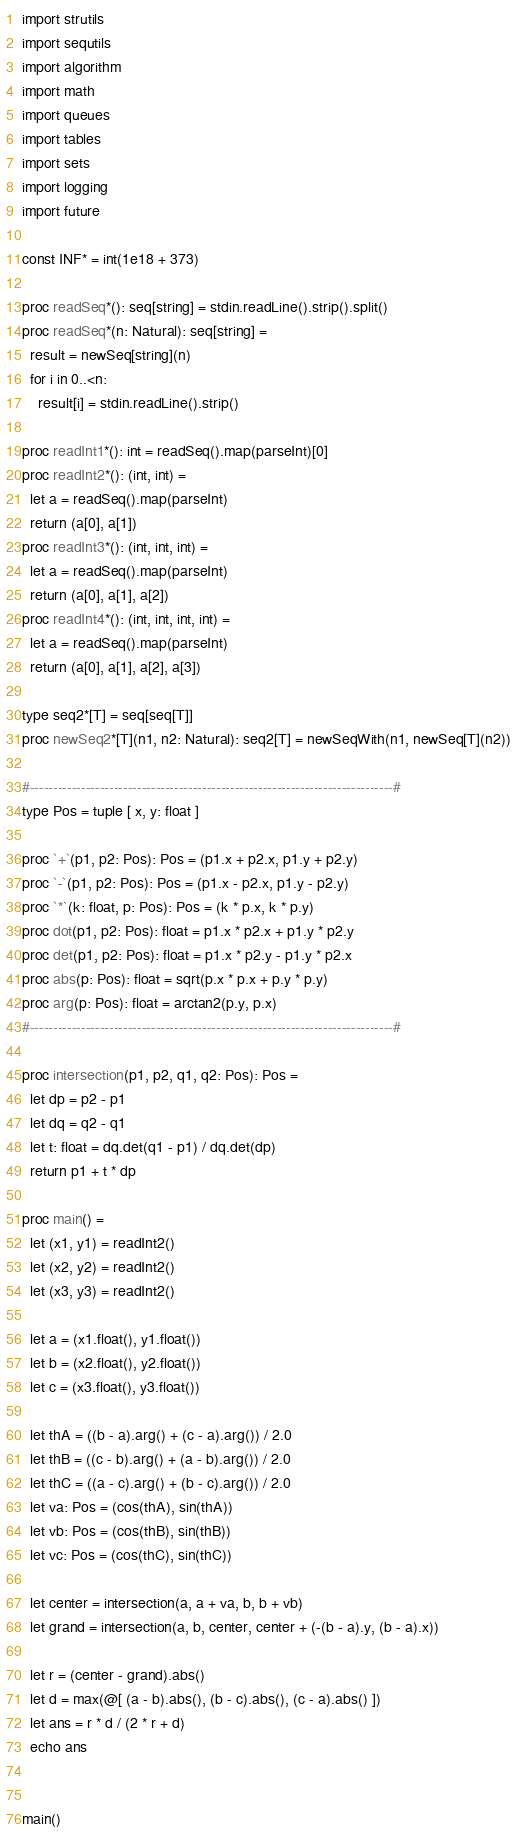Convert code to text. <code><loc_0><loc_0><loc_500><loc_500><_Nim_>import strutils
import sequtils
import algorithm
import math
import queues
import tables
import sets
import logging
import future

const INF* = int(1e18 + 373)

proc readSeq*(): seq[string] = stdin.readLine().strip().split()
proc readSeq*(n: Natural): seq[string] =
  result = newSeq[string](n)
  for i in 0..<n:
    result[i] = stdin.readLine().strip()

proc readInt1*(): int = readSeq().map(parseInt)[0]
proc readInt2*(): (int, int) =
  let a = readSeq().map(parseInt)
  return (a[0], a[1])
proc readInt3*(): (int, int, int) =
  let a = readSeq().map(parseInt)
  return (a[0], a[1], a[2])
proc readInt4*(): (int, int, int, int) =
  let a = readSeq().map(parseInt)
  return (a[0], a[1], a[2], a[3])

type seq2*[T] = seq[seq[T]]
proc newSeq2*[T](n1, n2: Natural): seq2[T] = newSeqWith(n1, newSeq[T](n2))

#------------------------------------------------------------------------------#
type Pos = tuple [ x, y: float ]

proc `+`(p1, p2: Pos): Pos = (p1.x + p2.x, p1.y + p2.y)
proc `-`(p1, p2: Pos): Pos = (p1.x - p2.x, p1.y - p2.y)
proc `*`(k: float, p: Pos): Pos = (k * p.x, k * p.y)
proc dot(p1, p2: Pos): float = p1.x * p2.x + p1.y * p2.y
proc det(p1, p2: Pos): float = p1.x * p2.y - p1.y * p2.x
proc abs(p: Pos): float = sqrt(p.x * p.x + p.y * p.y)
proc arg(p: Pos): float = arctan2(p.y, p.x)
#------------------------------------------------------------------------------#

proc intersection(p1, p2, q1, q2: Pos): Pos =
  let dp = p2 - p1
  let dq = q2 - q1
  let t: float = dq.det(q1 - p1) / dq.det(dp)
  return p1 + t * dp

proc main() =
  let (x1, y1) = readInt2()
  let (x2, y2) = readInt2()
  let (x3, y3) = readInt2()

  let a = (x1.float(), y1.float())
  let b = (x2.float(), y2.float())
  let c = (x3.float(), y3.float())

  let thA = ((b - a).arg() + (c - a).arg()) / 2.0
  let thB = ((c - b).arg() + (a - b).arg()) / 2.0
  let thC = ((a - c).arg() + (b - c).arg()) / 2.0
  let va: Pos = (cos(thA), sin(thA))
  let vb: Pos = (cos(thB), sin(thB))
  let vc: Pos = (cos(thC), sin(thC))

  let center = intersection(a, a + va, b, b + vb)
  let grand = intersection(a, b, center, center + (-(b - a).y, (b - a).x))

  let r = (center - grand).abs()
  let d = max(@[ (a - b).abs(), (b - c).abs(), (c - a).abs() ])
  let ans = r * d / (2 * r + d)
  echo ans


main()

</code> 